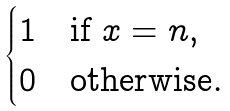<formula> <loc_0><loc_0><loc_500><loc_500>\begin{cases} 1 & \text {if $x = n$} , \\ 0 & \text {otherwise} . \end{cases}</formula> 